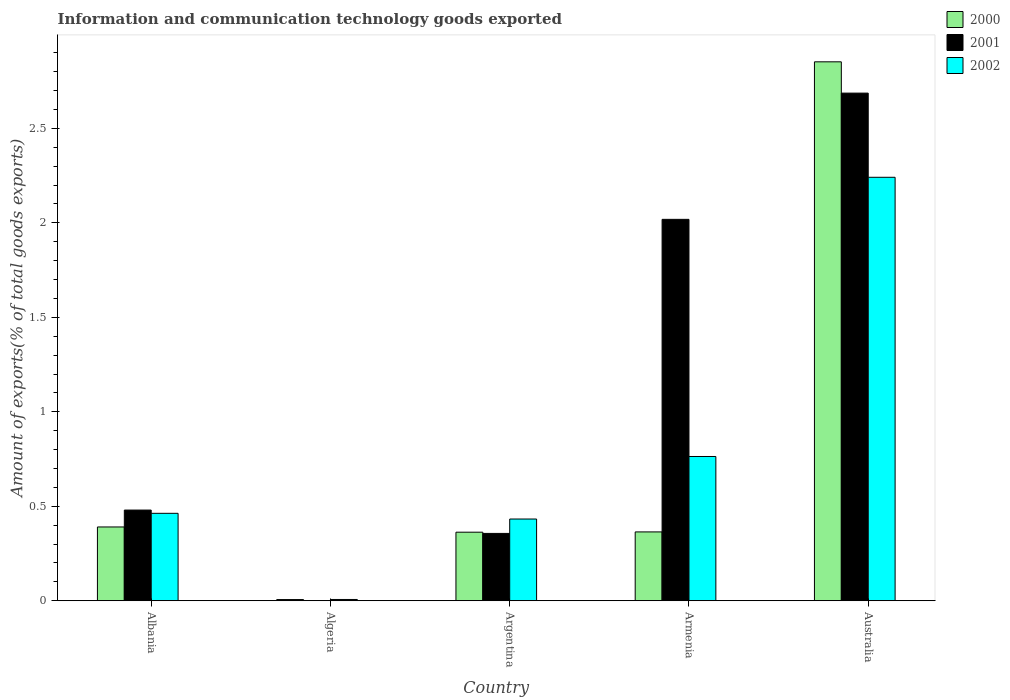How many different coloured bars are there?
Provide a short and direct response. 3. How many bars are there on the 5th tick from the right?
Ensure brevity in your answer.  3. What is the amount of goods exported in 2002 in Argentina?
Offer a very short reply. 0.43. Across all countries, what is the maximum amount of goods exported in 2001?
Provide a short and direct response. 2.69. Across all countries, what is the minimum amount of goods exported in 2000?
Provide a short and direct response. 0.01. In which country was the amount of goods exported in 2000 maximum?
Your answer should be very brief. Australia. In which country was the amount of goods exported in 2000 minimum?
Provide a short and direct response. Algeria. What is the total amount of goods exported in 2002 in the graph?
Offer a terse response. 3.91. What is the difference between the amount of goods exported in 2001 in Albania and that in Argentina?
Give a very brief answer. 0.12. What is the difference between the amount of goods exported in 2001 in Algeria and the amount of goods exported in 2002 in Australia?
Your answer should be compact. -2.24. What is the average amount of goods exported in 2002 per country?
Your answer should be compact. 0.78. What is the difference between the amount of goods exported of/in 2001 and amount of goods exported of/in 2002 in Armenia?
Your response must be concise. 1.25. In how many countries, is the amount of goods exported in 2001 greater than 0.9 %?
Offer a very short reply. 2. What is the ratio of the amount of goods exported in 2002 in Algeria to that in Argentina?
Your response must be concise. 0.02. Is the amount of goods exported in 2002 in Algeria less than that in Armenia?
Provide a short and direct response. Yes. Is the difference between the amount of goods exported in 2001 in Algeria and Armenia greater than the difference between the amount of goods exported in 2002 in Algeria and Armenia?
Make the answer very short. No. What is the difference between the highest and the second highest amount of goods exported in 2000?
Provide a short and direct response. 0.03. What is the difference between the highest and the lowest amount of goods exported in 2001?
Offer a terse response. 2.69. Is the sum of the amount of goods exported in 2001 in Argentina and Armenia greater than the maximum amount of goods exported in 2002 across all countries?
Ensure brevity in your answer.  Yes. What does the 3rd bar from the left in Australia represents?
Offer a very short reply. 2002. How many bars are there?
Your answer should be compact. 15. Are the values on the major ticks of Y-axis written in scientific E-notation?
Give a very brief answer. No. Does the graph contain any zero values?
Offer a terse response. No. Does the graph contain grids?
Ensure brevity in your answer.  No. What is the title of the graph?
Keep it short and to the point. Information and communication technology goods exported. What is the label or title of the Y-axis?
Your response must be concise. Amount of exports(% of total goods exports). What is the Amount of exports(% of total goods exports) in 2000 in Albania?
Keep it short and to the point. 0.39. What is the Amount of exports(% of total goods exports) in 2001 in Albania?
Ensure brevity in your answer.  0.48. What is the Amount of exports(% of total goods exports) in 2002 in Albania?
Offer a terse response. 0.46. What is the Amount of exports(% of total goods exports) in 2000 in Algeria?
Provide a succinct answer. 0.01. What is the Amount of exports(% of total goods exports) in 2001 in Algeria?
Offer a terse response. 0. What is the Amount of exports(% of total goods exports) of 2002 in Algeria?
Provide a short and direct response. 0.01. What is the Amount of exports(% of total goods exports) in 2000 in Argentina?
Make the answer very short. 0.36. What is the Amount of exports(% of total goods exports) of 2001 in Argentina?
Your response must be concise. 0.36. What is the Amount of exports(% of total goods exports) in 2002 in Argentina?
Make the answer very short. 0.43. What is the Amount of exports(% of total goods exports) of 2000 in Armenia?
Offer a terse response. 0.36. What is the Amount of exports(% of total goods exports) of 2001 in Armenia?
Your answer should be compact. 2.02. What is the Amount of exports(% of total goods exports) of 2002 in Armenia?
Keep it short and to the point. 0.76. What is the Amount of exports(% of total goods exports) of 2000 in Australia?
Offer a very short reply. 2.85. What is the Amount of exports(% of total goods exports) of 2001 in Australia?
Provide a succinct answer. 2.69. What is the Amount of exports(% of total goods exports) of 2002 in Australia?
Your answer should be very brief. 2.24. Across all countries, what is the maximum Amount of exports(% of total goods exports) in 2000?
Offer a terse response. 2.85. Across all countries, what is the maximum Amount of exports(% of total goods exports) of 2001?
Make the answer very short. 2.69. Across all countries, what is the maximum Amount of exports(% of total goods exports) in 2002?
Provide a succinct answer. 2.24. Across all countries, what is the minimum Amount of exports(% of total goods exports) in 2000?
Provide a succinct answer. 0.01. Across all countries, what is the minimum Amount of exports(% of total goods exports) in 2001?
Your answer should be compact. 0. Across all countries, what is the minimum Amount of exports(% of total goods exports) in 2002?
Offer a terse response. 0.01. What is the total Amount of exports(% of total goods exports) of 2000 in the graph?
Offer a very short reply. 3.98. What is the total Amount of exports(% of total goods exports) of 2001 in the graph?
Your answer should be compact. 5.54. What is the total Amount of exports(% of total goods exports) of 2002 in the graph?
Provide a short and direct response. 3.91. What is the difference between the Amount of exports(% of total goods exports) of 2000 in Albania and that in Algeria?
Provide a short and direct response. 0.38. What is the difference between the Amount of exports(% of total goods exports) in 2001 in Albania and that in Algeria?
Offer a very short reply. 0.48. What is the difference between the Amount of exports(% of total goods exports) of 2002 in Albania and that in Algeria?
Your answer should be compact. 0.46. What is the difference between the Amount of exports(% of total goods exports) in 2000 in Albania and that in Argentina?
Your response must be concise. 0.03. What is the difference between the Amount of exports(% of total goods exports) in 2001 in Albania and that in Argentina?
Give a very brief answer. 0.12. What is the difference between the Amount of exports(% of total goods exports) of 2002 in Albania and that in Argentina?
Keep it short and to the point. 0.03. What is the difference between the Amount of exports(% of total goods exports) in 2000 in Albania and that in Armenia?
Make the answer very short. 0.03. What is the difference between the Amount of exports(% of total goods exports) in 2001 in Albania and that in Armenia?
Provide a succinct answer. -1.54. What is the difference between the Amount of exports(% of total goods exports) in 2002 in Albania and that in Armenia?
Offer a terse response. -0.3. What is the difference between the Amount of exports(% of total goods exports) of 2000 in Albania and that in Australia?
Your answer should be compact. -2.46. What is the difference between the Amount of exports(% of total goods exports) in 2001 in Albania and that in Australia?
Give a very brief answer. -2.21. What is the difference between the Amount of exports(% of total goods exports) of 2002 in Albania and that in Australia?
Make the answer very short. -1.78. What is the difference between the Amount of exports(% of total goods exports) in 2000 in Algeria and that in Argentina?
Give a very brief answer. -0.36. What is the difference between the Amount of exports(% of total goods exports) of 2001 in Algeria and that in Argentina?
Provide a short and direct response. -0.36. What is the difference between the Amount of exports(% of total goods exports) in 2002 in Algeria and that in Argentina?
Offer a terse response. -0.43. What is the difference between the Amount of exports(% of total goods exports) of 2000 in Algeria and that in Armenia?
Your answer should be compact. -0.36. What is the difference between the Amount of exports(% of total goods exports) of 2001 in Algeria and that in Armenia?
Provide a succinct answer. -2.02. What is the difference between the Amount of exports(% of total goods exports) of 2002 in Algeria and that in Armenia?
Your answer should be very brief. -0.76. What is the difference between the Amount of exports(% of total goods exports) in 2000 in Algeria and that in Australia?
Offer a very short reply. -2.85. What is the difference between the Amount of exports(% of total goods exports) of 2001 in Algeria and that in Australia?
Give a very brief answer. -2.69. What is the difference between the Amount of exports(% of total goods exports) of 2002 in Algeria and that in Australia?
Keep it short and to the point. -2.23. What is the difference between the Amount of exports(% of total goods exports) in 2000 in Argentina and that in Armenia?
Offer a very short reply. -0. What is the difference between the Amount of exports(% of total goods exports) in 2001 in Argentina and that in Armenia?
Your response must be concise. -1.66. What is the difference between the Amount of exports(% of total goods exports) in 2002 in Argentina and that in Armenia?
Your answer should be very brief. -0.33. What is the difference between the Amount of exports(% of total goods exports) of 2000 in Argentina and that in Australia?
Offer a very short reply. -2.49. What is the difference between the Amount of exports(% of total goods exports) in 2001 in Argentina and that in Australia?
Your answer should be very brief. -2.33. What is the difference between the Amount of exports(% of total goods exports) in 2002 in Argentina and that in Australia?
Ensure brevity in your answer.  -1.81. What is the difference between the Amount of exports(% of total goods exports) in 2000 in Armenia and that in Australia?
Offer a terse response. -2.49. What is the difference between the Amount of exports(% of total goods exports) of 2001 in Armenia and that in Australia?
Your answer should be very brief. -0.67. What is the difference between the Amount of exports(% of total goods exports) of 2002 in Armenia and that in Australia?
Your response must be concise. -1.48. What is the difference between the Amount of exports(% of total goods exports) in 2000 in Albania and the Amount of exports(% of total goods exports) in 2001 in Algeria?
Your answer should be very brief. 0.39. What is the difference between the Amount of exports(% of total goods exports) in 2000 in Albania and the Amount of exports(% of total goods exports) in 2002 in Algeria?
Offer a terse response. 0.38. What is the difference between the Amount of exports(% of total goods exports) in 2001 in Albania and the Amount of exports(% of total goods exports) in 2002 in Algeria?
Give a very brief answer. 0.47. What is the difference between the Amount of exports(% of total goods exports) of 2000 in Albania and the Amount of exports(% of total goods exports) of 2001 in Argentina?
Make the answer very short. 0.03. What is the difference between the Amount of exports(% of total goods exports) of 2000 in Albania and the Amount of exports(% of total goods exports) of 2002 in Argentina?
Your answer should be compact. -0.04. What is the difference between the Amount of exports(% of total goods exports) in 2001 in Albania and the Amount of exports(% of total goods exports) in 2002 in Argentina?
Ensure brevity in your answer.  0.05. What is the difference between the Amount of exports(% of total goods exports) in 2000 in Albania and the Amount of exports(% of total goods exports) in 2001 in Armenia?
Make the answer very short. -1.63. What is the difference between the Amount of exports(% of total goods exports) in 2000 in Albania and the Amount of exports(% of total goods exports) in 2002 in Armenia?
Keep it short and to the point. -0.37. What is the difference between the Amount of exports(% of total goods exports) in 2001 in Albania and the Amount of exports(% of total goods exports) in 2002 in Armenia?
Offer a very short reply. -0.28. What is the difference between the Amount of exports(% of total goods exports) of 2000 in Albania and the Amount of exports(% of total goods exports) of 2001 in Australia?
Keep it short and to the point. -2.3. What is the difference between the Amount of exports(% of total goods exports) of 2000 in Albania and the Amount of exports(% of total goods exports) of 2002 in Australia?
Give a very brief answer. -1.85. What is the difference between the Amount of exports(% of total goods exports) in 2001 in Albania and the Amount of exports(% of total goods exports) in 2002 in Australia?
Your answer should be compact. -1.76. What is the difference between the Amount of exports(% of total goods exports) of 2000 in Algeria and the Amount of exports(% of total goods exports) of 2001 in Argentina?
Offer a very short reply. -0.35. What is the difference between the Amount of exports(% of total goods exports) of 2000 in Algeria and the Amount of exports(% of total goods exports) of 2002 in Argentina?
Ensure brevity in your answer.  -0.43. What is the difference between the Amount of exports(% of total goods exports) in 2001 in Algeria and the Amount of exports(% of total goods exports) in 2002 in Argentina?
Keep it short and to the point. -0.43. What is the difference between the Amount of exports(% of total goods exports) in 2000 in Algeria and the Amount of exports(% of total goods exports) in 2001 in Armenia?
Your response must be concise. -2.01. What is the difference between the Amount of exports(% of total goods exports) in 2000 in Algeria and the Amount of exports(% of total goods exports) in 2002 in Armenia?
Offer a very short reply. -0.76. What is the difference between the Amount of exports(% of total goods exports) in 2001 in Algeria and the Amount of exports(% of total goods exports) in 2002 in Armenia?
Provide a succinct answer. -0.76. What is the difference between the Amount of exports(% of total goods exports) of 2000 in Algeria and the Amount of exports(% of total goods exports) of 2001 in Australia?
Provide a short and direct response. -2.68. What is the difference between the Amount of exports(% of total goods exports) of 2000 in Algeria and the Amount of exports(% of total goods exports) of 2002 in Australia?
Your answer should be very brief. -2.23. What is the difference between the Amount of exports(% of total goods exports) in 2001 in Algeria and the Amount of exports(% of total goods exports) in 2002 in Australia?
Provide a succinct answer. -2.24. What is the difference between the Amount of exports(% of total goods exports) in 2000 in Argentina and the Amount of exports(% of total goods exports) in 2001 in Armenia?
Provide a succinct answer. -1.66. What is the difference between the Amount of exports(% of total goods exports) of 2000 in Argentina and the Amount of exports(% of total goods exports) of 2002 in Armenia?
Offer a very short reply. -0.4. What is the difference between the Amount of exports(% of total goods exports) in 2001 in Argentina and the Amount of exports(% of total goods exports) in 2002 in Armenia?
Offer a terse response. -0.41. What is the difference between the Amount of exports(% of total goods exports) of 2000 in Argentina and the Amount of exports(% of total goods exports) of 2001 in Australia?
Your answer should be compact. -2.32. What is the difference between the Amount of exports(% of total goods exports) of 2000 in Argentina and the Amount of exports(% of total goods exports) of 2002 in Australia?
Provide a short and direct response. -1.88. What is the difference between the Amount of exports(% of total goods exports) of 2001 in Argentina and the Amount of exports(% of total goods exports) of 2002 in Australia?
Give a very brief answer. -1.88. What is the difference between the Amount of exports(% of total goods exports) in 2000 in Armenia and the Amount of exports(% of total goods exports) in 2001 in Australia?
Make the answer very short. -2.32. What is the difference between the Amount of exports(% of total goods exports) in 2000 in Armenia and the Amount of exports(% of total goods exports) in 2002 in Australia?
Provide a short and direct response. -1.88. What is the difference between the Amount of exports(% of total goods exports) of 2001 in Armenia and the Amount of exports(% of total goods exports) of 2002 in Australia?
Keep it short and to the point. -0.22. What is the average Amount of exports(% of total goods exports) in 2000 per country?
Provide a short and direct response. 0.8. What is the average Amount of exports(% of total goods exports) of 2001 per country?
Make the answer very short. 1.11. What is the average Amount of exports(% of total goods exports) in 2002 per country?
Ensure brevity in your answer.  0.78. What is the difference between the Amount of exports(% of total goods exports) of 2000 and Amount of exports(% of total goods exports) of 2001 in Albania?
Offer a very short reply. -0.09. What is the difference between the Amount of exports(% of total goods exports) in 2000 and Amount of exports(% of total goods exports) in 2002 in Albania?
Offer a terse response. -0.07. What is the difference between the Amount of exports(% of total goods exports) of 2001 and Amount of exports(% of total goods exports) of 2002 in Albania?
Make the answer very short. 0.02. What is the difference between the Amount of exports(% of total goods exports) of 2000 and Amount of exports(% of total goods exports) of 2001 in Algeria?
Provide a short and direct response. 0.01. What is the difference between the Amount of exports(% of total goods exports) in 2000 and Amount of exports(% of total goods exports) in 2002 in Algeria?
Make the answer very short. -0. What is the difference between the Amount of exports(% of total goods exports) of 2001 and Amount of exports(% of total goods exports) of 2002 in Algeria?
Your answer should be very brief. -0.01. What is the difference between the Amount of exports(% of total goods exports) of 2000 and Amount of exports(% of total goods exports) of 2001 in Argentina?
Keep it short and to the point. 0.01. What is the difference between the Amount of exports(% of total goods exports) of 2000 and Amount of exports(% of total goods exports) of 2002 in Argentina?
Keep it short and to the point. -0.07. What is the difference between the Amount of exports(% of total goods exports) of 2001 and Amount of exports(% of total goods exports) of 2002 in Argentina?
Your answer should be very brief. -0.08. What is the difference between the Amount of exports(% of total goods exports) of 2000 and Amount of exports(% of total goods exports) of 2001 in Armenia?
Provide a succinct answer. -1.65. What is the difference between the Amount of exports(% of total goods exports) of 2000 and Amount of exports(% of total goods exports) of 2002 in Armenia?
Ensure brevity in your answer.  -0.4. What is the difference between the Amount of exports(% of total goods exports) in 2001 and Amount of exports(% of total goods exports) in 2002 in Armenia?
Provide a short and direct response. 1.25. What is the difference between the Amount of exports(% of total goods exports) in 2000 and Amount of exports(% of total goods exports) in 2001 in Australia?
Give a very brief answer. 0.17. What is the difference between the Amount of exports(% of total goods exports) of 2000 and Amount of exports(% of total goods exports) of 2002 in Australia?
Give a very brief answer. 0.61. What is the difference between the Amount of exports(% of total goods exports) of 2001 and Amount of exports(% of total goods exports) of 2002 in Australia?
Provide a short and direct response. 0.45. What is the ratio of the Amount of exports(% of total goods exports) of 2000 in Albania to that in Algeria?
Provide a succinct answer. 60.18. What is the ratio of the Amount of exports(% of total goods exports) in 2001 in Albania to that in Algeria?
Your answer should be compact. 415.79. What is the ratio of the Amount of exports(% of total goods exports) of 2002 in Albania to that in Algeria?
Give a very brief answer. 67.04. What is the ratio of the Amount of exports(% of total goods exports) in 2000 in Albania to that in Argentina?
Ensure brevity in your answer.  1.08. What is the ratio of the Amount of exports(% of total goods exports) in 2001 in Albania to that in Argentina?
Provide a succinct answer. 1.35. What is the ratio of the Amount of exports(% of total goods exports) in 2002 in Albania to that in Argentina?
Keep it short and to the point. 1.07. What is the ratio of the Amount of exports(% of total goods exports) in 2000 in Albania to that in Armenia?
Provide a succinct answer. 1.07. What is the ratio of the Amount of exports(% of total goods exports) in 2001 in Albania to that in Armenia?
Your answer should be very brief. 0.24. What is the ratio of the Amount of exports(% of total goods exports) in 2002 in Albania to that in Armenia?
Make the answer very short. 0.61. What is the ratio of the Amount of exports(% of total goods exports) in 2000 in Albania to that in Australia?
Your answer should be very brief. 0.14. What is the ratio of the Amount of exports(% of total goods exports) of 2001 in Albania to that in Australia?
Provide a succinct answer. 0.18. What is the ratio of the Amount of exports(% of total goods exports) in 2002 in Albania to that in Australia?
Provide a succinct answer. 0.21. What is the ratio of the Amount of exports(% of total goods exports) in 2000 in Algeria to that in Argentina?
Make the answer very short. 0.02. What is the ratio of the Amount of exports(% of total goods exports) in 2001 in Algeria to that in Argentina?
Ensure brevity in your answer.  0. What is the ratio of the Amount of exports(% of total goods exports) in 2002 in Algeria to that in Argentina?
Provide a succinct answer. 0.02. What is the ratio of the Amount of exports(% of total goods exports) in 2000 in Algeria to that in Armenia?
Your answer should be compact. 0.02. What is the ratio of the Amount of exports(% of total goods exports) in 2001 in Algeria to that in Armenia?
Give a very brief answer. 0. What is the ratio of the Amount of exports(% of total goods exports) of 2002 in Algeria to that in Armenia?
Provide a short and direct response. 0.01. What is the ratio of the Amount of exports(% of total goods exports) in 2000 in Algeria to that in Australia?
Offer a very short reply. 0. What is the ratio of the Amount of exports(% of total goods exports) of 2002 in Algeria to that in Australia?
Provide a short and direct response. 0. What is the ratio of the Amount of exports(% of total goods exports) of 2001 in Argentina to that in Armenia?
Make the answer very short. 0.18. What is the ratio of the Amount of exports(% of total goods exports) in 2002 in Argentina to that in Armenia?
Provide a succinct answer. 0.57. What is the ratio of the Amount of exports(% of total goods exports) of 2000 in Argentina to that in Australia?
Your response must be concise. 0.13. What is the ratio of the Amount of exports(% of total goods exports) of 2001 in Argentina to that in Australia?
Your answer should be very brief. 0.13. What is the ratio of the Amount of exports(% of total goods exports) in 2002 in Argentina to that in Australia?
Provide a succinct answer. 0.19. What is the ratio of the Amount of exports(% of total goods exports) in 2000 in Armenia to that in Australia?
Offer a terse response. 0.13. What is the ratio of the Amount of exports(% of total goods exports) in 2001 in Armenia to that in Australia?
Provide a short and direct response. 0.75. What is the ratio of the Amount of exports(% of total goods exports) of 2002 in Armenia to that in Australia?
Offer a terse response. 0.34. What is the difference between the highest and the second highest Amount of exports(% of total goods exports) of 2000?
Offer a terse response. 2.46. What is the difference between the highest and the second highest Amount of exports(% of total goods exports) of 2001?
Your answer should be compact. 0.67. What is the difference between the highest and the second highest Amount of exports(% of total goods exports) in 2002?
Provide a succinct answer. 1.48. What is the difference between the highest and the lowest Amount of exports(% of total goods exports) in 2000?
Provide a succinct answer. 2.85. What is the difference between the highest and the lowest Amount of exports(% of total goods exports) of 2001?
Your response must be concise. 2.69. What is the difference between the highest and the lowest Amount of exports(% of total goods exports) in 2002?
Provide a succinct answer. 2.23. 